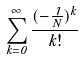<formula> <loc_0><loc_0><loc_500><loc_500>\sum _ { k = 0 } ^ { \infty } \frac { ( - \frac { 1 } { N } ) ^ { k } } { k ! }</formula> 